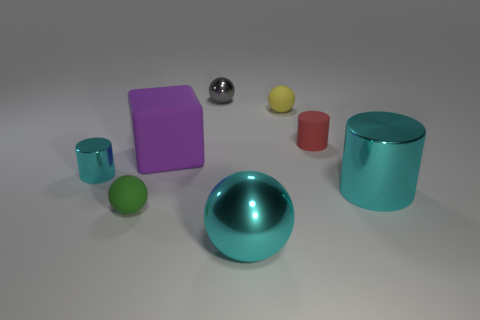Subtract all tiny balls. How many balls are left? 1 Add 1 red matte objects. How many objects exist? 9 Subtract all cyan cylinders. How many cylinders are left? 1 Subtract all cylinders. How many objects are left? 5 Subtract 2 spheres. How many spheres are left? 2 Subtract 0 blue cylinders. How many objects are left? 8 Subtract all cyan cylinders. Subtract all brown balls. How many cylinders are left? 1 Subtract all yellow blocks. How many cyan cylinders are left? 2 Subtract all tiny cyan matte objects. Subtract all cyan metallic things. How many objects are left? 5 Add 4 small balls. How many small balls are left? 7 